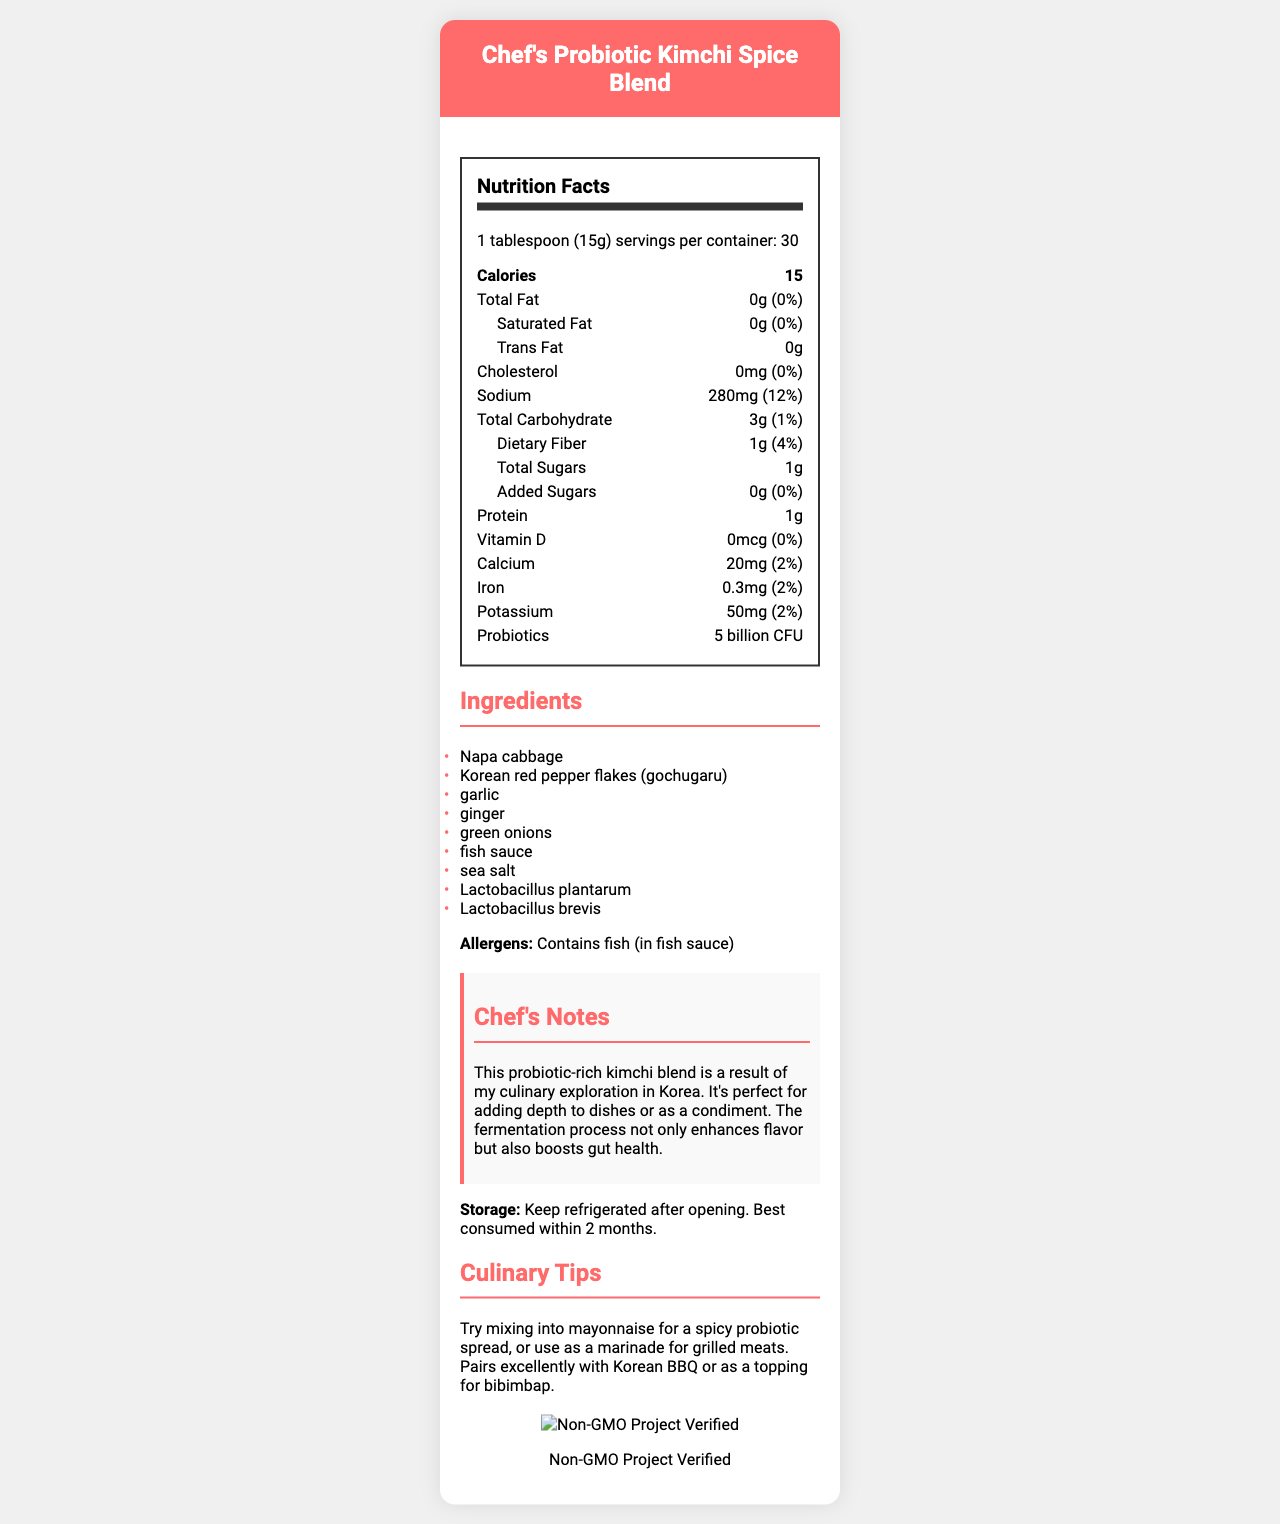what is the serving size? The serving size is clearly stated in the nutrition facts section at the top.
Answer: 1 tablespoon (15g) how many servings are in the container? The number of servings per container is listed just below the serving size in the nutrition facts.
Answer: 30 how many calories are there per serving? The calorie content per serving is prominently displayed in the nutrition facts.
Answer: 15 what is the amount of sodium in one serving? The amount of sodium per serving is listed in the nutrition facts under the "Sodium" section.
Answer: 280mg how much protein is in each serving? The amount of protein per serving is detailed in the nutrition facts.
Answer: 1g which ingredient is listed first? A. Fish sauce B. Napa cabbage C. Garlic D. Green onions Napa cabbage is the first ingredient in the list of ingredients.
Answer: B. Napa cabbage what is the daily value percentage of dietary fiber per serving? A. 1% B. 2% C. 4% D. 12% The daily value percentage of dietary fiber is listed as 4% in the nutrition facts.
Answer: C. 4% does the product contain added sugars? The nutrition facts explicitly show that there are 0g of added sugars, indicating no added sugars.
Answer: No is the product Non-GMO Project Verified? The certification section states that the product is Non-GMO Project Verified, and this is also depicted by the Non-GMO seal image.
Answer: Yes what are the probiotics present in the product? The amount of probiotics is listed in the nutrition facts as 5 billion CFU.
Answer: 5 billion CFU what allergens are present in this product? The allergens section mentions that the product contains fish, specifically in the fish sauce used.
Answer: Contains fish (in fish sauce) who is the targeted audience for the culinary tips? The culinary tips are practical advice aimed at individuals who enjoy cooking and experimenting in the kitchen.
Answer: Home cooks or culinary enthusiasts list the ingredients found in the product. All ingredients are clearly listed under the ingredients section.
Answer: Napa cabbage, Korean red pepper flakes (gochugaru), garlic, ginger, green onions, fish sauce, sea salt, Lactobacillus plantarum, Lactobacillus brevis how should the product be stored? The storage instructions mention that the product should be kept refrigerated after opening and is best consumed within 2 months.
Answer: Keep refrigerated after opening. Best consumed within 2 months. how does this product contribute to gut health? The chef's notes indicate that the fermentation process enhances flavor and boosts gut health, backed by the presence of 5 billion CFU probiotics.
Answer: Through its probiotics content and fermentation process which of the following is not an ingredient in the kimchi spice blend? A. Napa cabbage B. Korean red pepper flakes C. Honey D. Green onions The ingredient list does not mention honey as an ingredient.
Answer: C. Honey what does the chef suggest mixing this blend with for a spicy probiotic spread? The culinary tips suggest mixing the kimchi spice blend into mayonnaise for a spicy probiotic spread.
Answer: Mayonnaise what is the main purpose of this document? The document aims to inform about the nutritional content, ingredients, and usage ideas for Chef's Probiotic Kimchi Spice Blend, while highlighting its health benefits and storage requirements.
Answer: To provide detailed nutritional and ingredient information for Chef's Probiotic Kimchi Spice Blend, along with culinary tips and storage instructions. what is the chef's culinary background? The document provides information about the product but does not contain details about the chef's culinary background.
Answer: Cannot be determined 